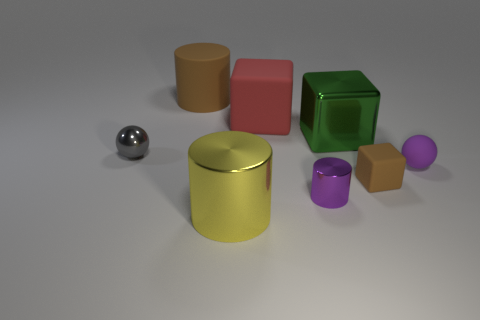Subtract all large red rubber cubes. How many cubes are left? 2 Subtract all green cubes. How many cubes are left? 2 Add 1 tiny green metal objects. How many objects exist? 9 Subtract all cylinders. How many objects are left? 5 Add 5 yellow rubber cylinders. How many yellow rubber cylinders exist? 5 Subtract 0 yellow blocks. How many objects are left? 8 Subtract all blue balls. Subtract all purple cubes. How many balls are left? 2 Subtract all big blue metal spheres. Subtract all large red matte objects. How many objects are left? 7 Add 7 matte blocks. How many matte blocks are left? 9 